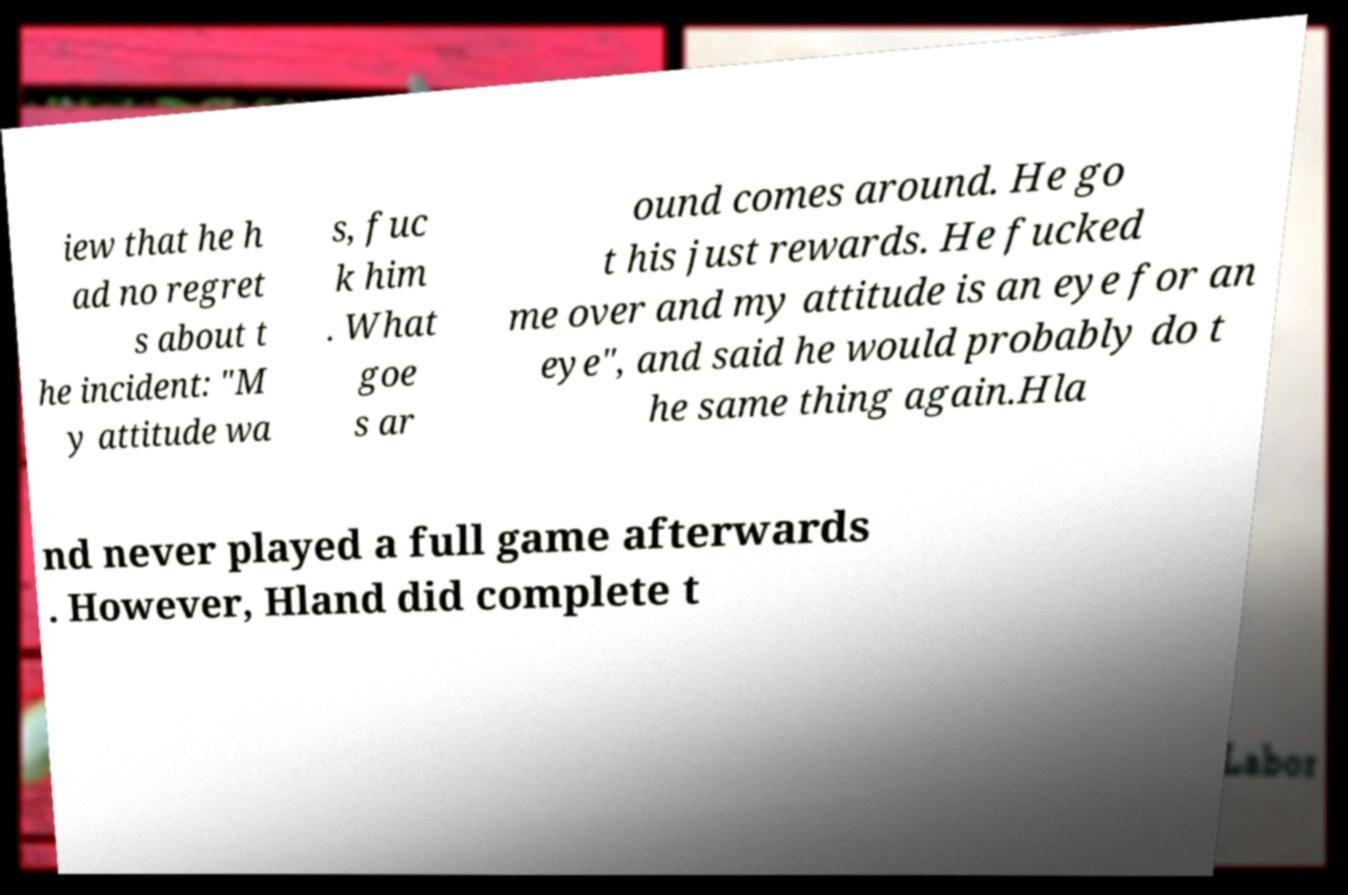Could you extract and type out the text from this image? iew that he h ad no regret s about t he incident: "M y attitude wa s, fuc k him . What goe s ar ound comes around. He go t his just rewards. He fucked me over and my attitude is an eye for an eye", and said he would probably do t he same thing again.Hla nd never played a full game afterwards . However, Hland did complete t 